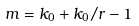<formula> <loc_0><loc_0><loc_500><loc_500>m = k _ { 0 } + k _ { 0 } / r - 1</formula> 